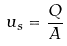Convert formula to latex. <formula><loc_0><loc_0><loc_500><loc_500>u _ { s } = \frac { Q } { A }</formula> 